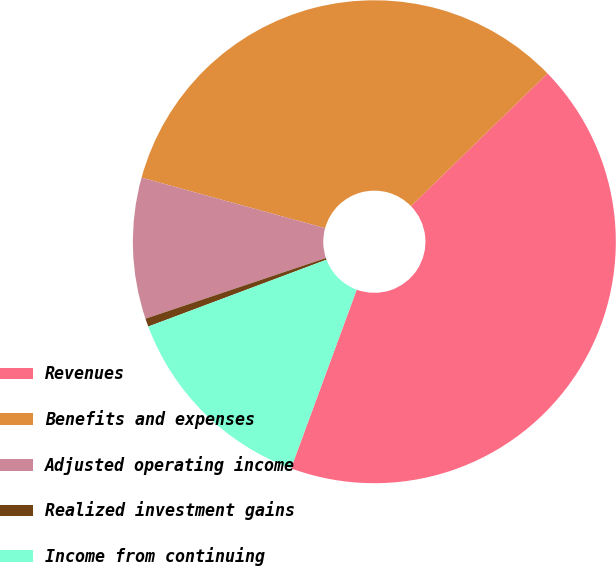Convert chart to OTSL. <chart><loc_0><loc_0><loc_500><loc_500><pie_chart><fcel>Revenues<fcel>Benefits and expenses<fcel>Adjusted operating income<fcel>Realized investment gains<fcel>Income from continuing<nl><fcel>42.89%<fcel>33.45%<fcel>9.44%<fcel>0.55%<fcel>13.68%<nl></chart> 